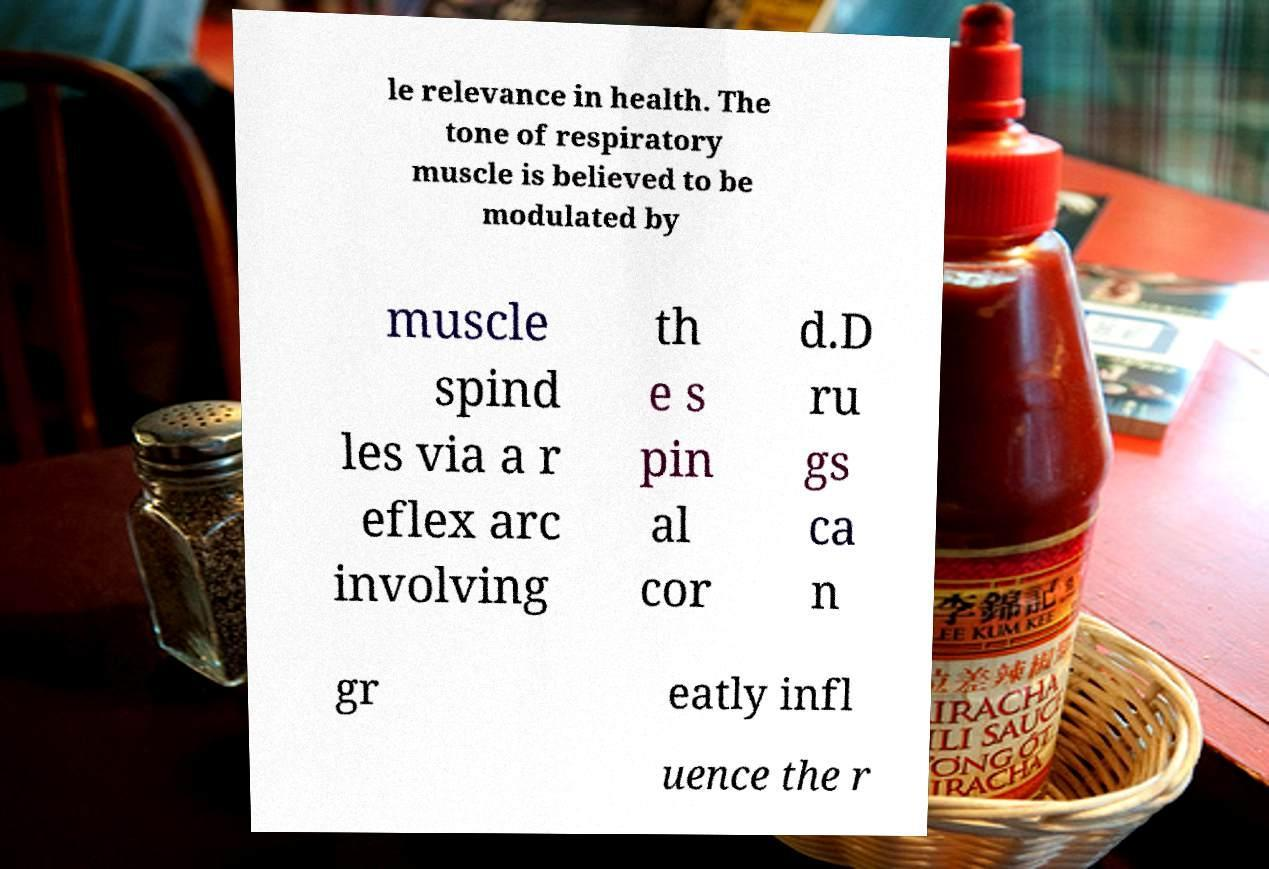There's text embedded in this image that I need extracted. Can you transcribe it verbatim? le relevance in health. The tone of respiratory muscle is believed to be modulated by muscle spind les via a r eflex arc involving th e s pin al cor d.D ru gs ca n gr eatly infl uence the r 